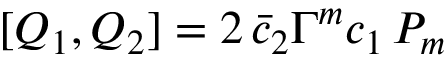Convert formula to latex. <formula><loc_0><loc_0><loc_500><loc_500>[ Q _ { 1 } , Q _ { 2 } ] = 2 \, \bar { c } _ { 2 } \Gamma ^ { m } c _ { 1 } \, P _ { m }</formula> 